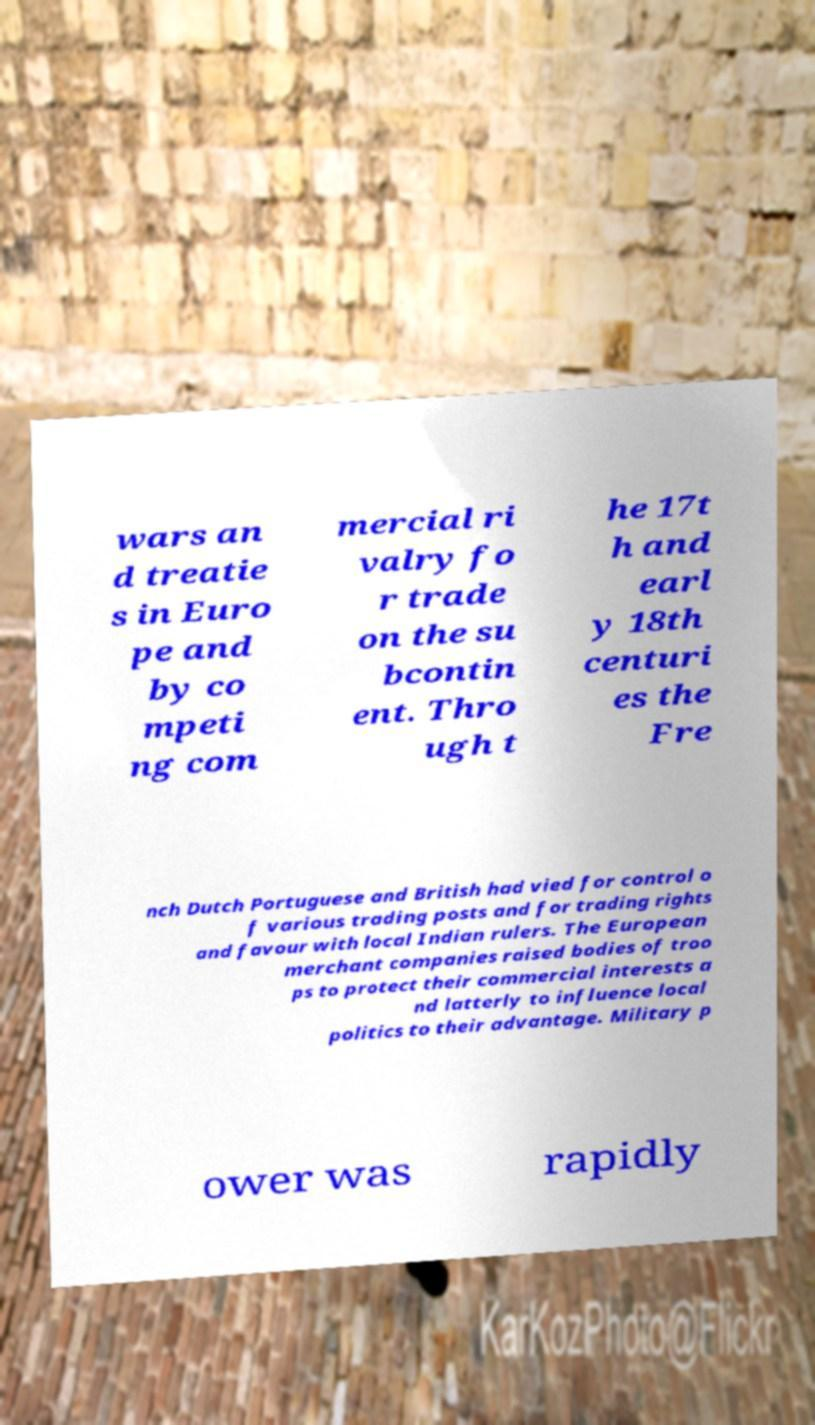Can you accurately transcribe the text from the provided image for me? wars an d treatie s in Euro pe and by co mpeti ng com mercial ri valry fo r trade on the su bcontin ent. Thro ugh t he 17t h and earl y 18th centuri es the Fre nch Dutch Portuguese and British had vied for control o f various trading posts and for trading rights and favour with local Indian rulers. The European merchant companies raised bodies of troo ps to protect their commercial interests a nd latterly to influence local politics to their advantage. Military p ower was rapidly 